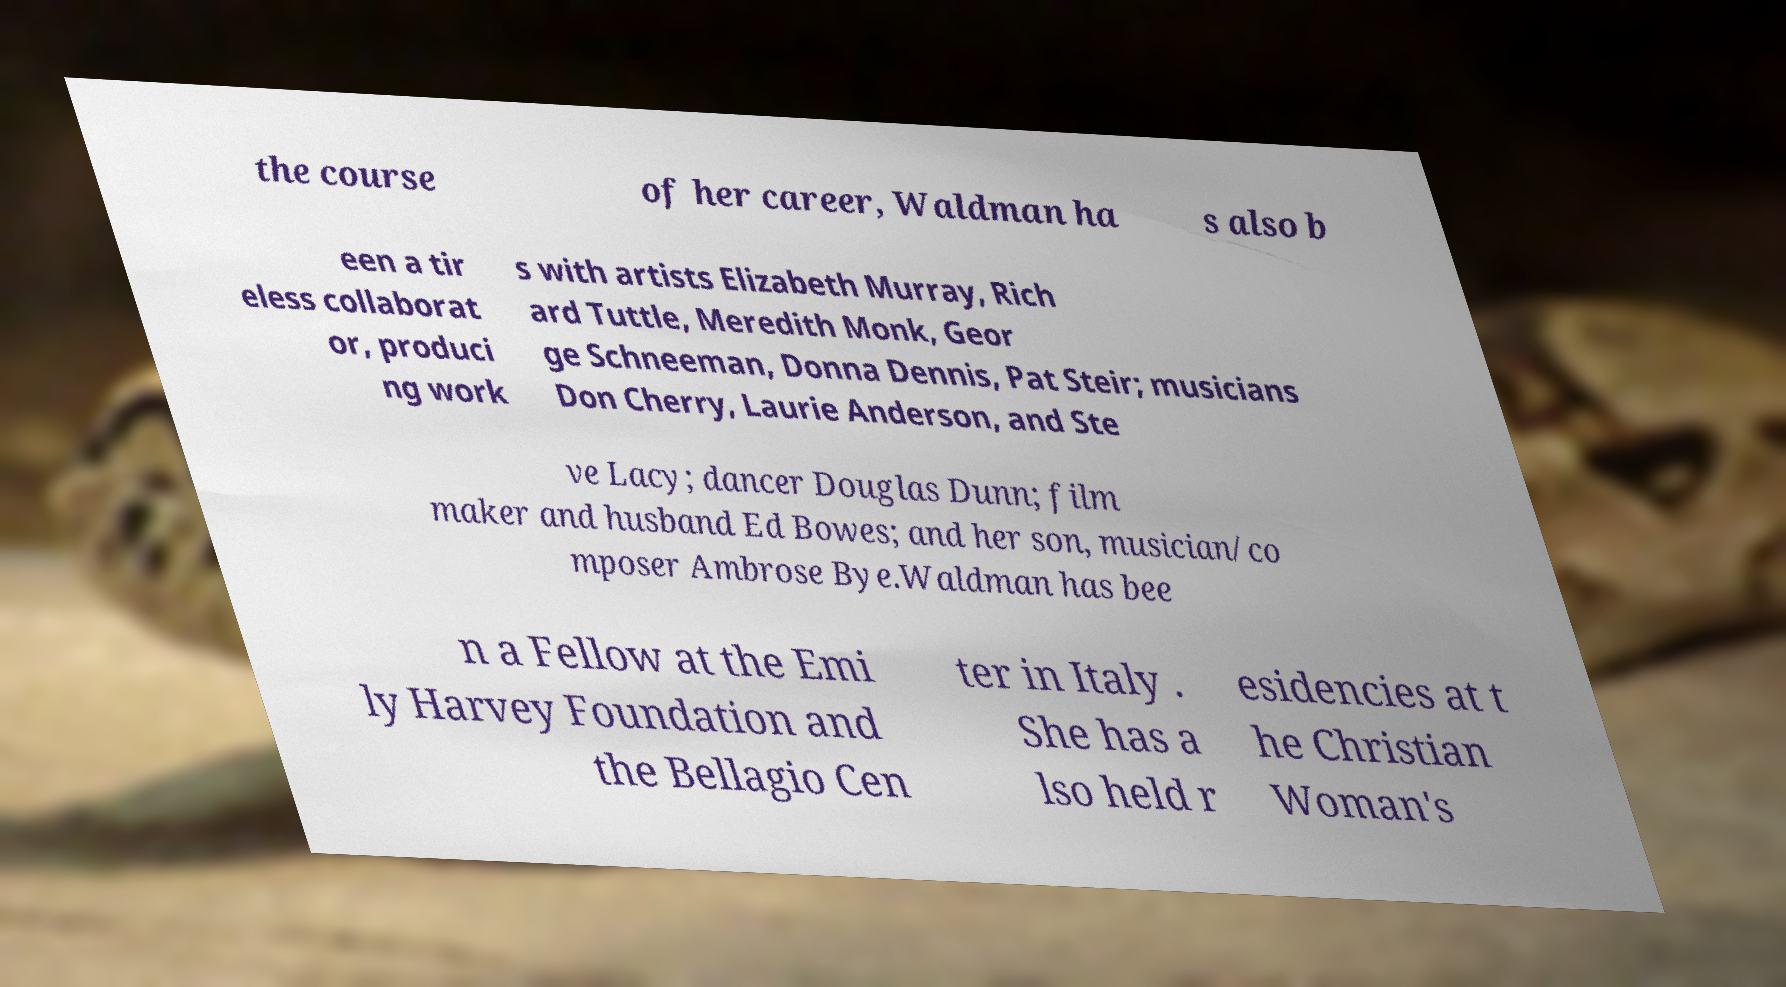Could you assist in decoding the text presented in this image and type it out clearly? the course of her career, Waldman ha s also b een a tir eless collaborat or, produci ng work s with artists Elizabeth Murray, Rich ard Tuttle, Meredith Monk, Geor ge Schneeman, Donna Dennis, Pat Steir; musicians Don Cherry, Laurie Anderson, and Ste ve Lacy; dancer Douglas Dunn; film maker and husband Ed Bowes; and her son, musician/co mposer Ambrose Bye.Waldman has bee n a Fellow at the Emi ly Harvey Foundation and the Bellagio Cen ter in Italy . She has a lso held r esidencies at t he Christian Woman's 